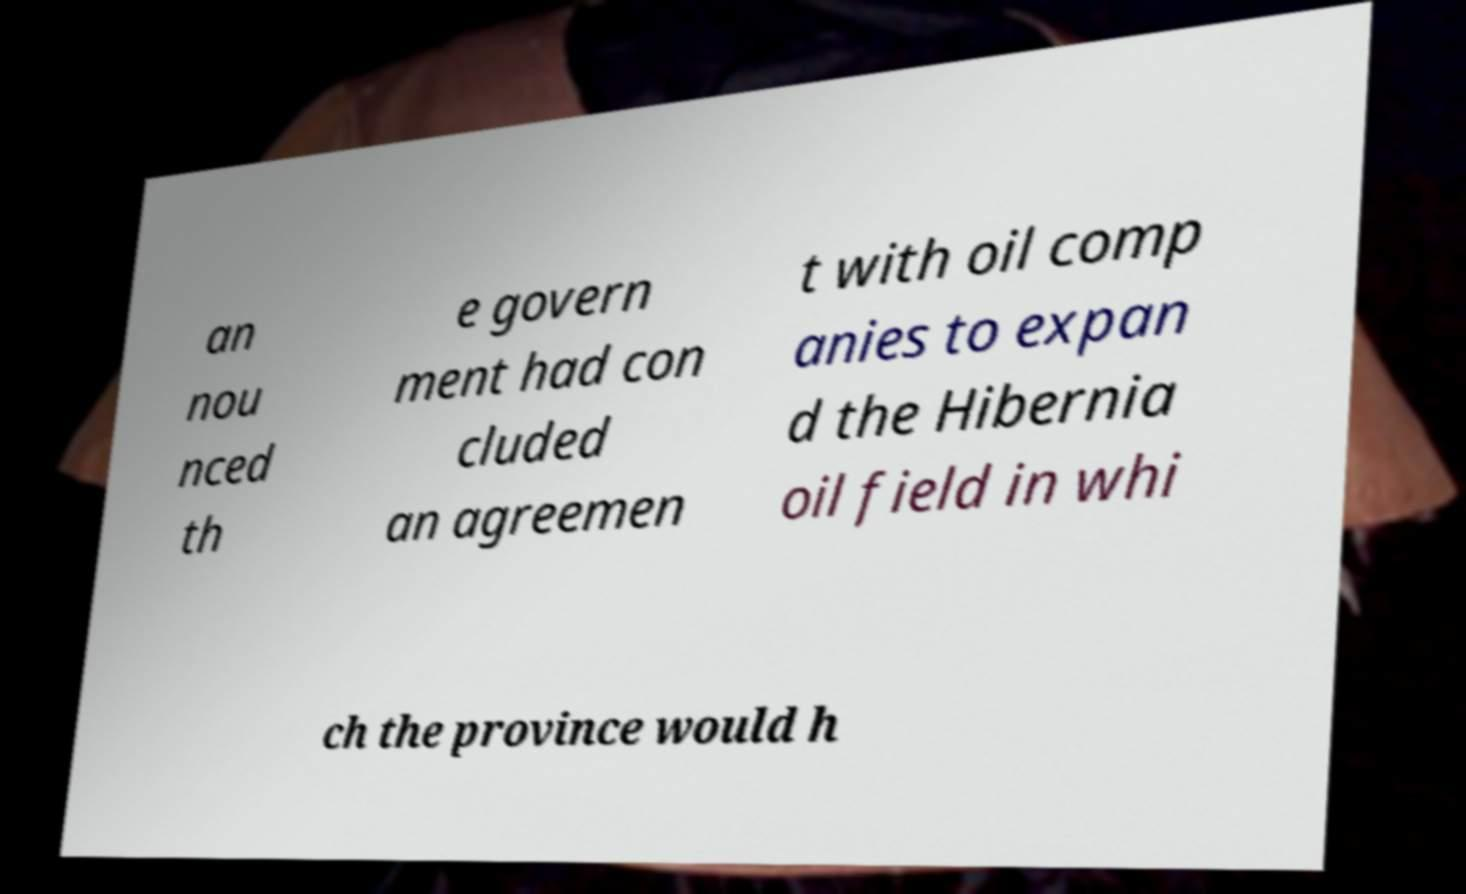There's text embedded in this image that I need extracted. Can you transcribe it verbatim? an nou nced th e govern ment had con cluded an agreemen t with oil comp anies to expan d the Hibernia oil field in whi ch the province would h 